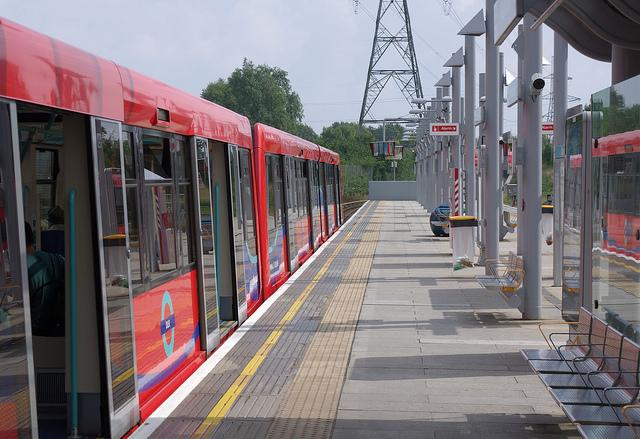What will the train do next? Please explain your reasoning. close doors. It will close the doors and leave. 